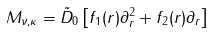Convert formula to latex. <formula><loc_0><loc_0><loc_500><loc_500>M _ { \nu , \kappa } = \tilde { D } _ { 0 } \left [ f _ { 1 } ( r ) \partial _ { r } ^ { 2 } + f _ { 2 } ( r ) \partial _ { r } \right ]</formula> 